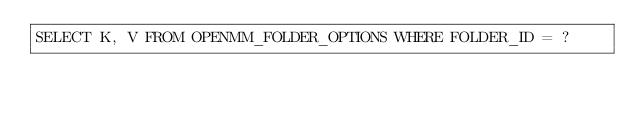<code> <loc_0><loc_0><loc_500><loc_500><_SQL_>SELECT K, V FROM OPENMM_FOLDER_OPTIONS WHERE FOLDER_ID = ?</code> 